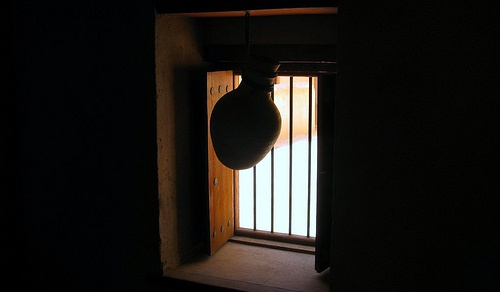Describe the objects in this image and their specific colors. I can see a vase in black, maroon, and brown tones in this image. 